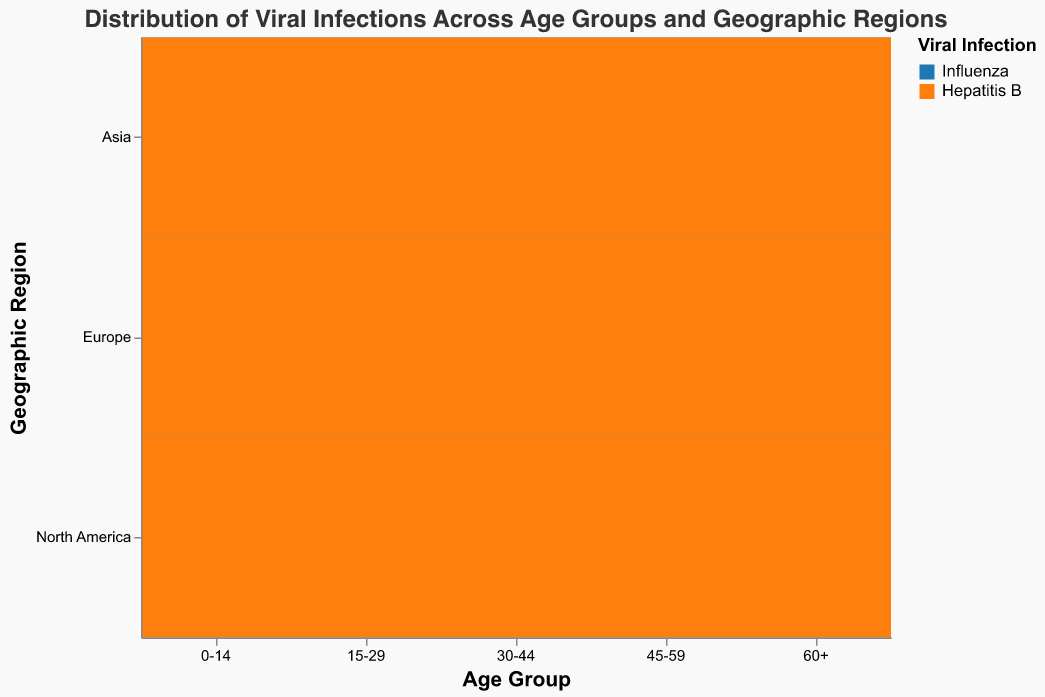What is the title of the figure? The title is displayed prominently at the top of the figure. It indicates the overall subject of the plot.
Answer: Distribution of Viral Infections Across Age Groups and Geographic Regions Which viral infection has the highest case count in the 60+ age group in North America? By locating the 60+ age group along the x-axis and North America along the y-axis, and then observing the largest rectangle in size, the color indicates which viral infection it represents.
Answer: Influenza What is the count of Hepatitis B cases in the 0-14 age group in Asia? Search for the cell that intersects the 0-14 age group (x-axis) and Asia (y-axis). Identify the rectangle matching the color for Hepatitis B and check the size or tooltip for the count.
Answer: 450 Which age group in Europe has the smallest count of Hepatitis B cases? Look at the Europe row across different age groups and check for the smallest rectangle representing Hepatitis B by observing the color and size.
Answer: 60+ Compare the cases of Influenza between the age groups of 15-29 and 45-59 in Asia. Which age group has more cases? First, identify the rectangles for Influenza in Asia for both age groups (15-29 and 45-59). Compare their sizes or counts.
Answer: 45-59 What is the sum of the case counts for Hepatitis B in North America? Sum the counts of Hepatitis B cases across all age groups in North America by finding each rectangle's value.
Answer: 310 + 580 + 420 + 290 + 180 = 1780 Which geographic region has the highest total count of Influenza cases? Total the counts of Influenza cases across all age groups for each region and compare.
Answer: Asia How does the distribution of Influenza cases differ between the 0-14 age group and the 60+ age group across all regions? Observe the relative sizes and counts of rectangles representing Influenza for both age groups across North America, Europe, and Asia. Compare the overall patterns.
Answer: The 60+ age group generally has larger counts than the 0-14 age group across all regions In which age group and geographic region combination is the case count for Hepatitis B exactly half of the Influenza case count? For each age group and region, find where the Hepatitis B count is half of the Influenza count.
Answer: Age 15-29 in North America and Age 15-29 in Asia What is the most common viral infection across geographic regions among the age group 30-44? For the 30-44 age group, examine which viral infection rectangles are larger across North America, Europe, and Asia to determine the commonality.
Answer: Influenza 